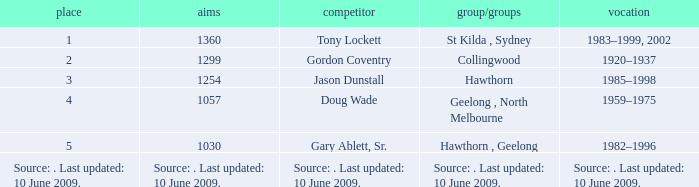In what club(s) does Tony Lockett play? St Kilda , Sydney. 